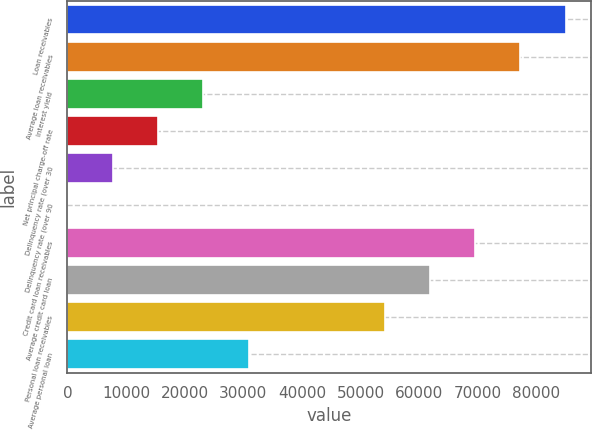<chart> <loc_0><loc_0><loc_500><loc_500><bar_chart><fcel>Loan receivables<fcel>Average loan receivables<fcel>Interest yield<fcel>Net principal charge-off rate<fcel>Delinquency rate (over 30<fcel>Delinquency rate (over 90<fcel>Credit card loan receivables<fcel>Average credit card loan<fcel>Personal loan receivables<fcel>Average personal loan<nl><fcel>84979.3<fcel>77254<fcel>23176.8<fcel>15451.5<fcel>7726.18<fcel>0.87<fcel>69528.7<fcel>61803.3<fcel>54078<fcel>30902.1<nl></chart> 